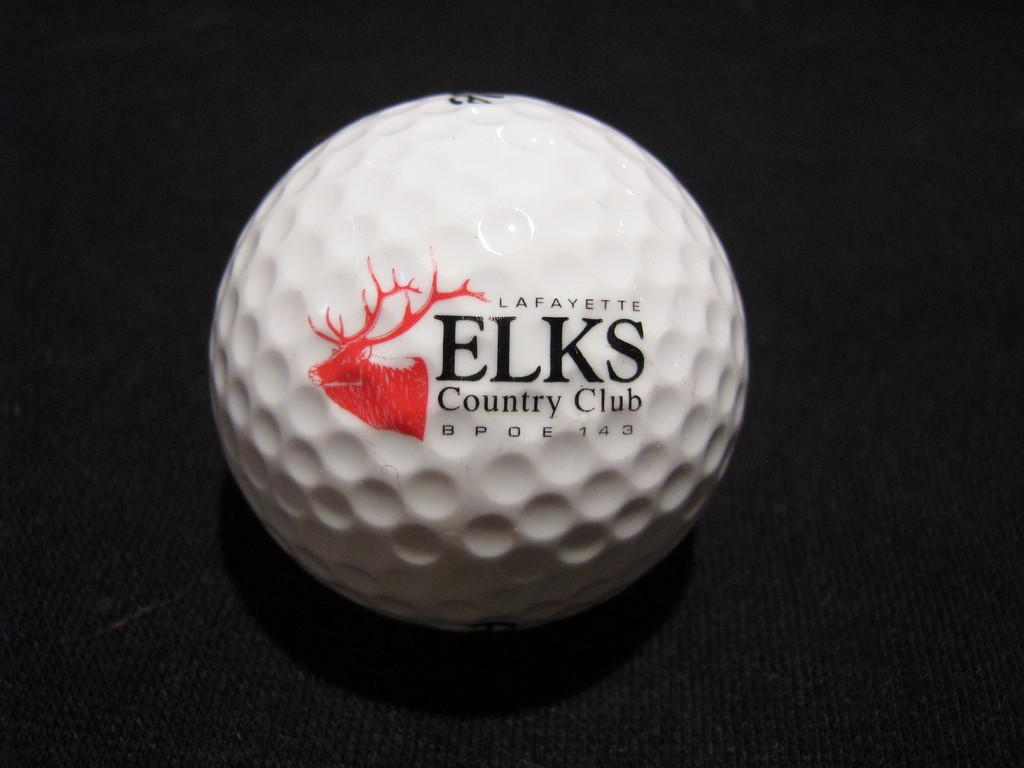What is the main object in the center of the image? There is a ball in the center of the image. What is written or depicted on the ball? There is text on the ball. What is located at the bottom of the image? There is a table at the bottom of the image. What type of doctor is standing next to the ball in the image? There is no doctor present in the image; it only features a ball and a table. 